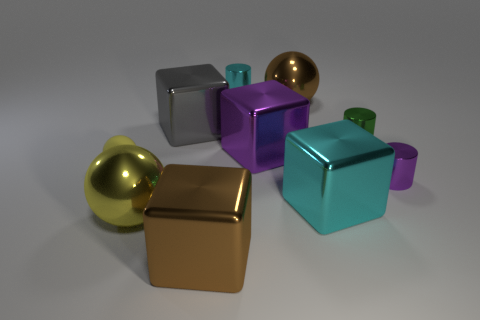Subtract all cylinders. How many objects are left? 7 Add 6 purple metallic cylinders. How many purple metallic cylinders exist? 7 Subtract 0 yellow blocks. How many objects are left? 10 Subtract all green matte objects. Subtract all large yellow shiny balls. How many objects are left? 9 Add 4 yellow shiny things. How many yellow shiny things are left? 5 